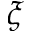<formula> <loc_0><loc_0><loc_500><loc_500>\xi</formula> 